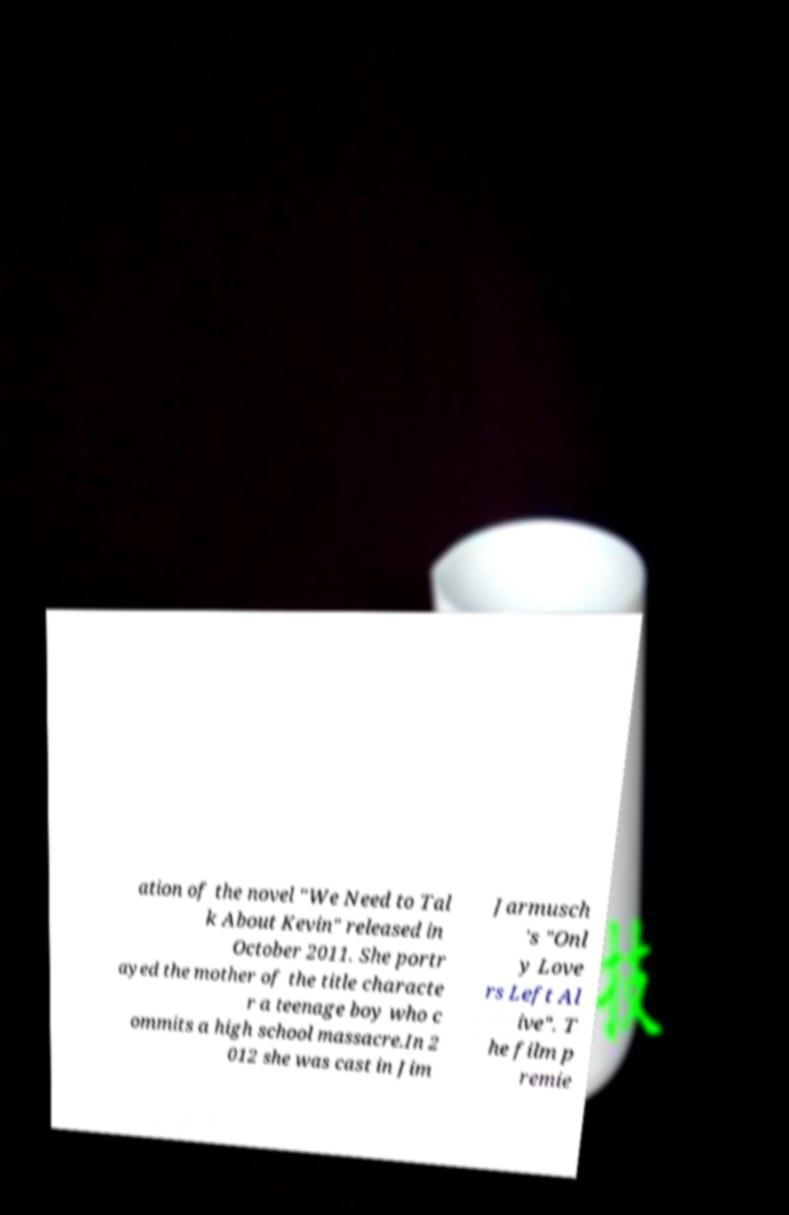Please read and relay the text visible in this image. What does it say? ation of the novel "We Need to Tal k About Kevin" released in October 2011. She portr ayed the mother of the title characte r a teenage boy who c ommits a high school massacre.In 2 012 she was cast in Jim Jarmusch 's "Onl y Love rs Left Al ive". T he film p remie 